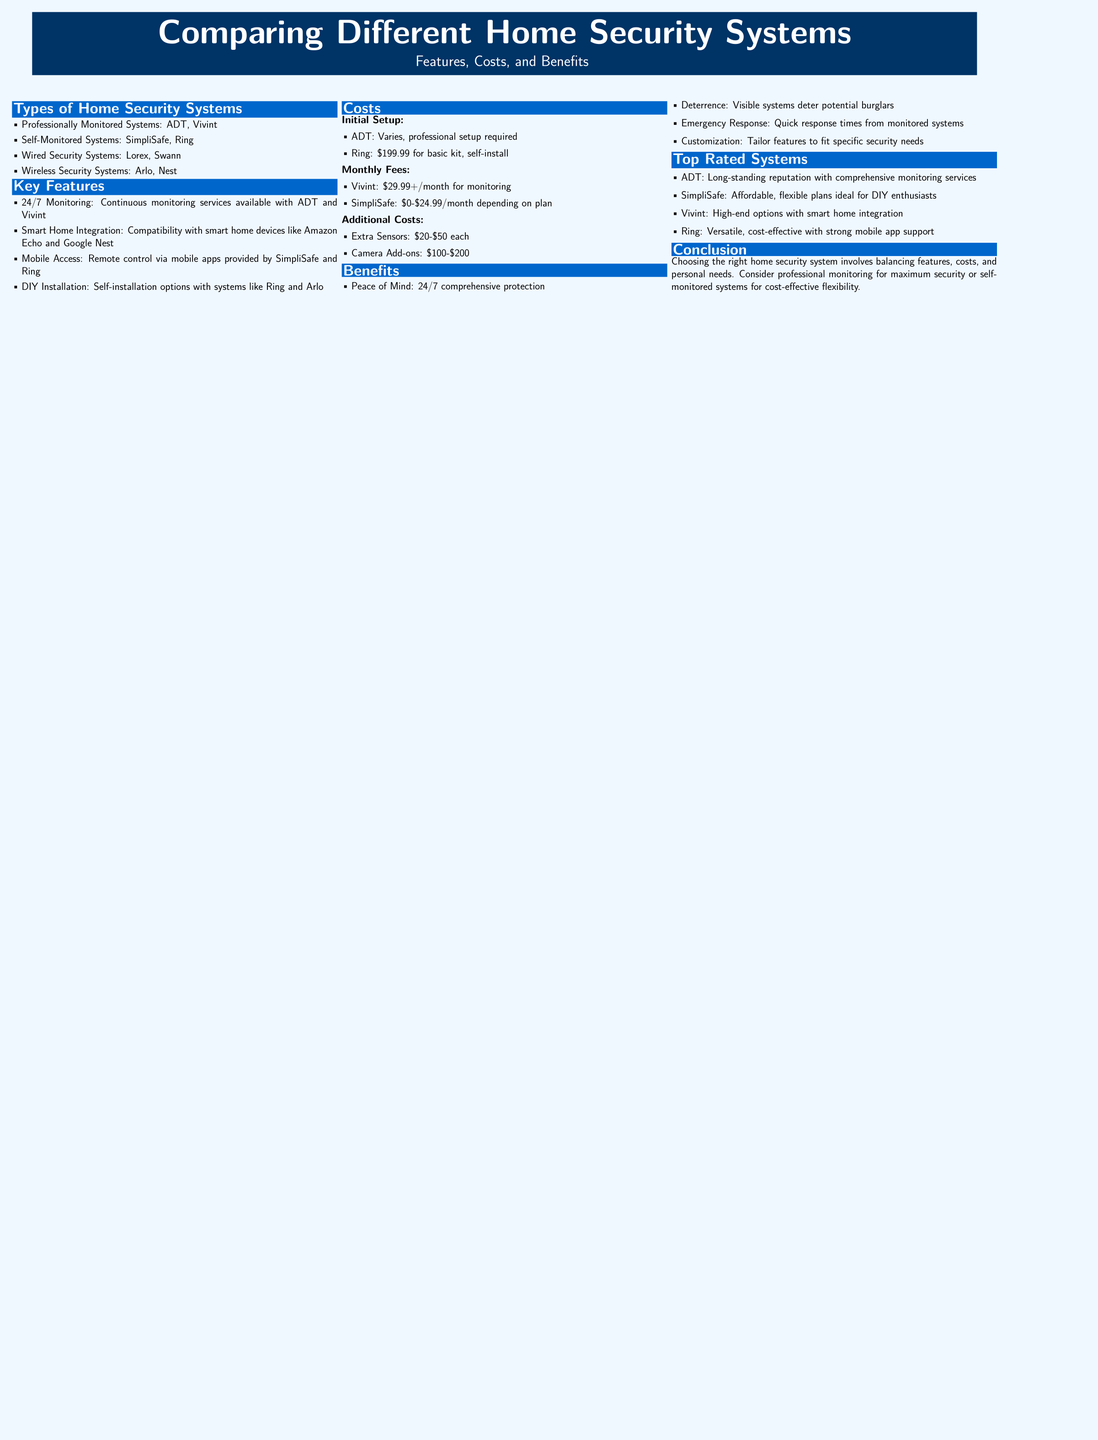What are some examples of professionally monitored systems? The document lists ADT and Vivint as examples of professionally monitored systems.
Answer: ADT, Vivint What is the cost of a basic Ring kit? According to the document, the basic kit for Ring costs $199.99 for self-installation.
Answer: $199.99 Which system offers 24/7 monitoring? The document mentions that ADT and Vivint provide continuous monitoring services, indicating they offer 24/7 monitoring.
Answer: ADT, Vivint What is the monthly fee for Vivint? The document specifies the monthly fee for Vivint starts at $29.99.
Answer: $29.99 Which features are provided by SimpliSafe? The document states that SimpliSafe offers mobile access and DIY installation.
Answer: Mobile Access, DIY Installation What type of system is most flexible according to the benefits section? The benefits section infers that self-monitored systems provide cost-effective flexibility.
Answer: Self-monitored systems What is considered a top-rated system for smart home integration? Vivint is highlighted as a high-end option with smart home integration in the top-rated systems section.
Answer: Vivint What is the primary benefit of having emergency response from monitored systems? The document suggests that quick response times from monitored systems is a major benefit.
Answer: Quick response times What statement reflects the conclusion about choosing a home security system? The conclusion summarizes the importance of balancing features, costs, and personal needs when selecting a system.
Answer: Balance features, costs, and personal needs 